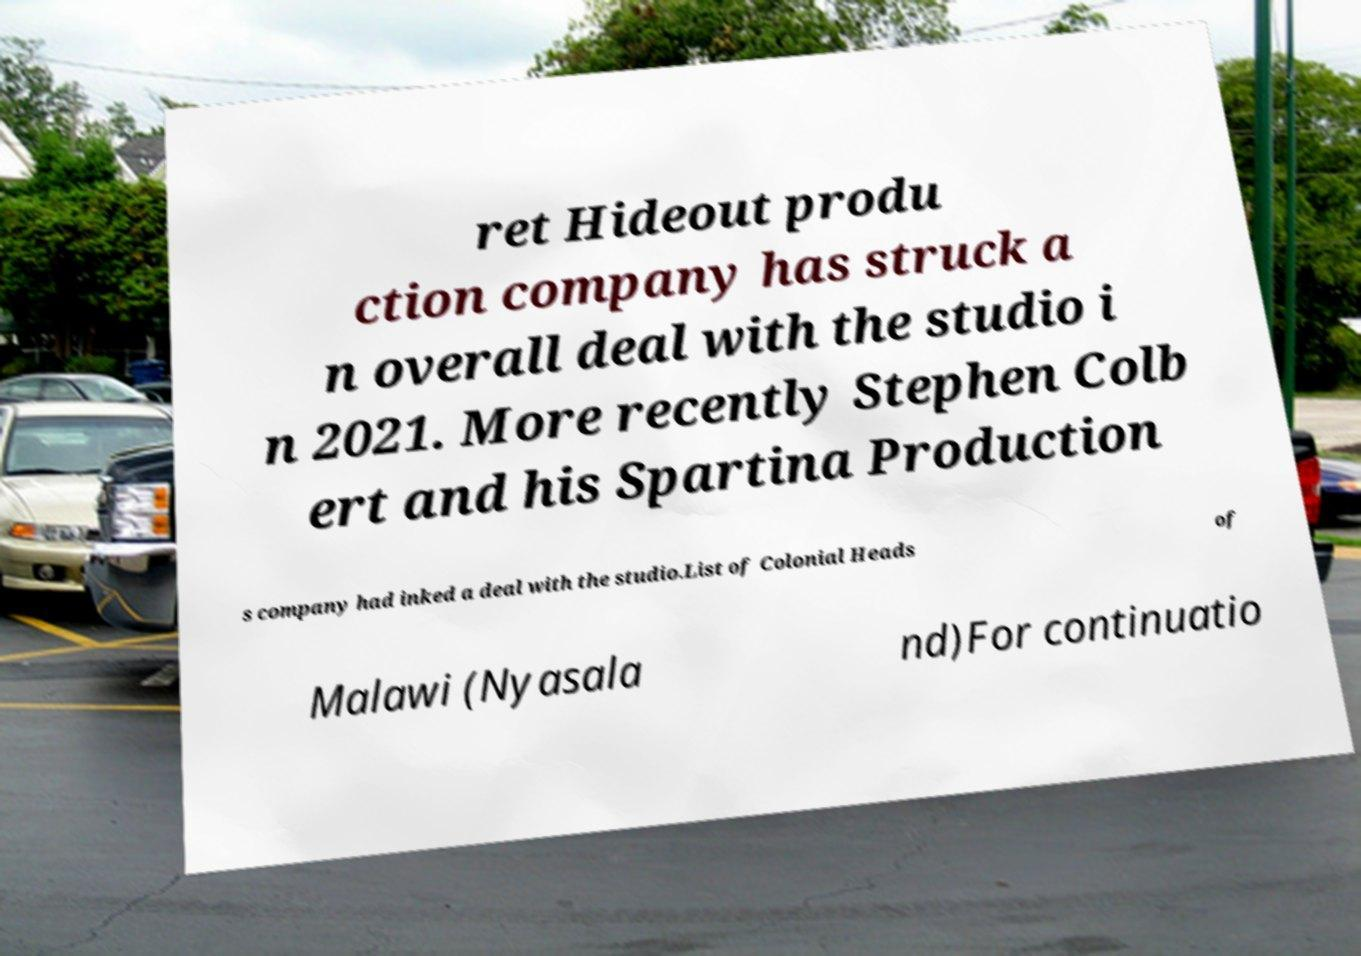For documentation purposes, I need the text within this image transcribed. Could you provide that? ret Hideout produ ction company has struck a n overall deal with the studio i n 2021. More recently Stephen Colb ert and his Spartina Production s company had inked a deal with the studio.List of Colonial Heads of Malawi (Nyasala nd)For continuatio 